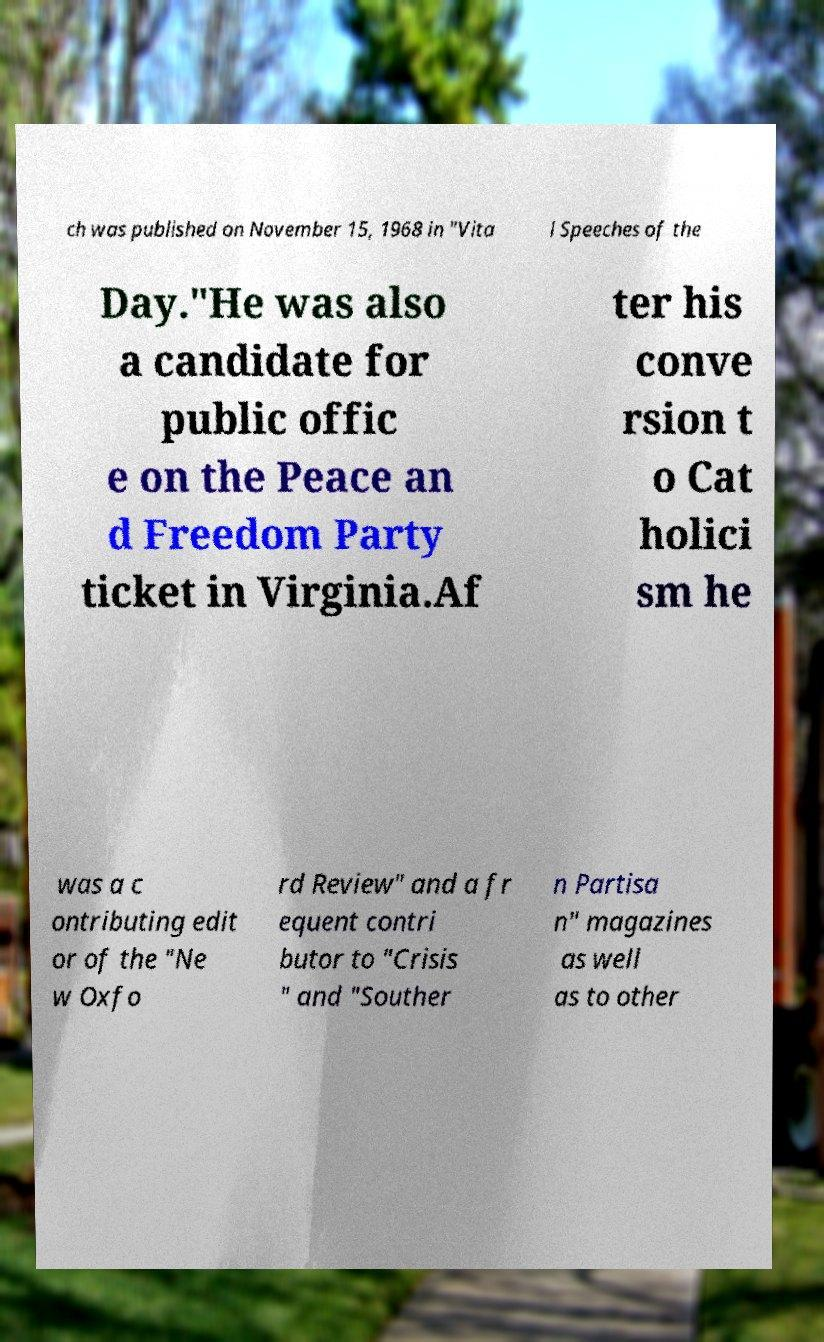Can you read and provide the text displayed in the image?This photo seems to have some interesting text. Can you extract and type it out for me? ch was published on November 15, 1968 in "Vita l Speeches of the Day."He was also a candidate for public offic e on the Peace an d Freedom Party ticket in Virginia.Af ter his conve rsion t o Cat holici sm he was a c ontributing edit or of the "Ne w Oxfo rd Review" and a fr equent contri butor to "Crisis " and "Souther n Partisa n" magazines as well as to other 